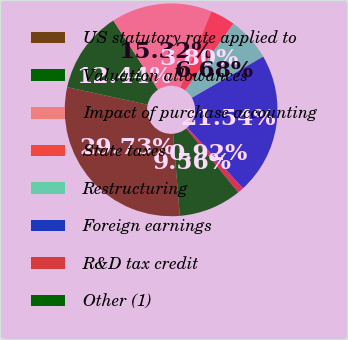Convert chart. <chart><loc_0><loc_0><loc_500><loc_500><pie_chart><fcel>US statutory rate applied to<fcel>Valuation allowances<fcel>Impact of purchase accounting<fcel>State taxes<fcel>Restructuring<fcel>Foreign earnings<fcel>R&D tax credit<fcel>Other (1)<nl><fcel>29.72%<fcel>12.44%<fcel>15.32%<fcel>3.8%<fcel>6.68%<fcel>21.54%<fcel>0.92%<fcel>9.56%<nl></chart> 